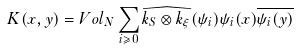<formula> <loc_0><loc_0><loc_500><loc_500>K ( x , y ) = V o l _ { N } \sum _ { i \geqslant 0 } \widehat { k _ { S } \otimes k _ { \xi } } ( \psi _ { i } ) \psi _ { i } ( x ) \overline { \psi _ { i } ( y ) }</formula> 